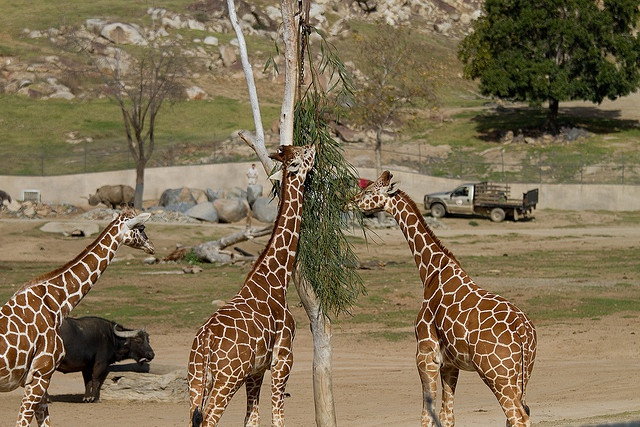Describe the objects in this image and their specific colors. I can see giraffe in olive, maroon, brown, and gray tones, giraffe in olive, maroon, black, and tan tones, giraffe in olive, maroon, lightgray, and gray tones, cow in olive, black, and gray tones, and truck in olive, black, gray, and darkgray tones in this image. 